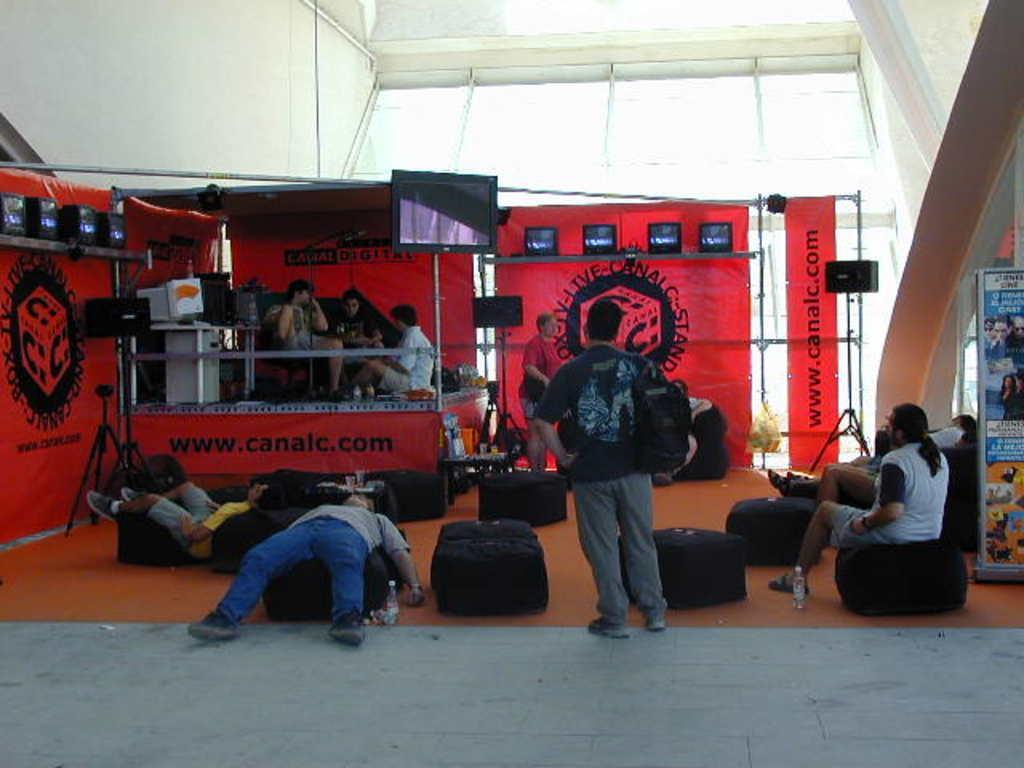Could you give a brief overview of what you see in this image? There are people and we can see chairs,bottles on the surface and devices with stands. We can see glasses and objects on the table,speakers,television and some objects on shelves. On the right side of the image we can see board,rods and red banners. In the background we can see wall and glass. 